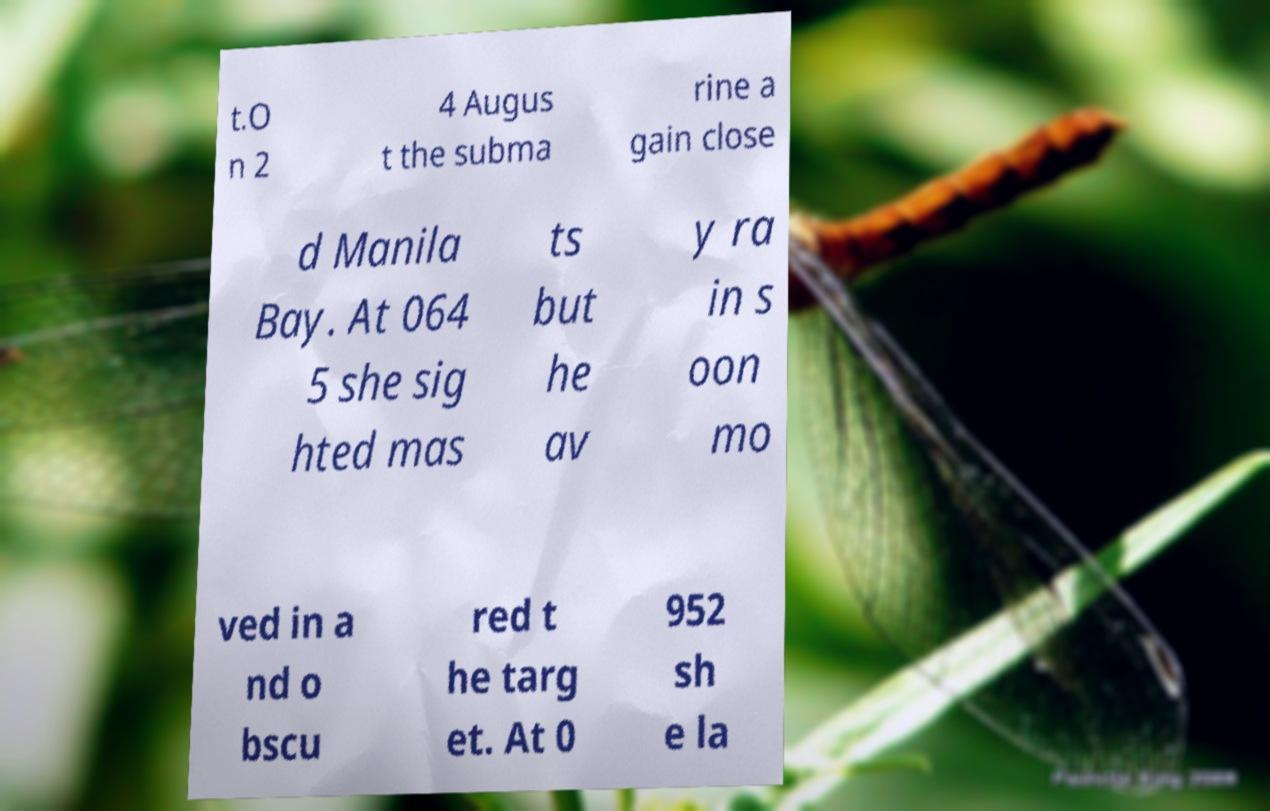Please read and relay the text visible in this image. What does it say? t.O n 2 4 Augus t the subma rine a gain close d Manila Bay. At 064 5 she sig hted mas ts but he av y ra in s oon mo ved in a nd o bscu red t he targ et. At 0 952 sh e la 